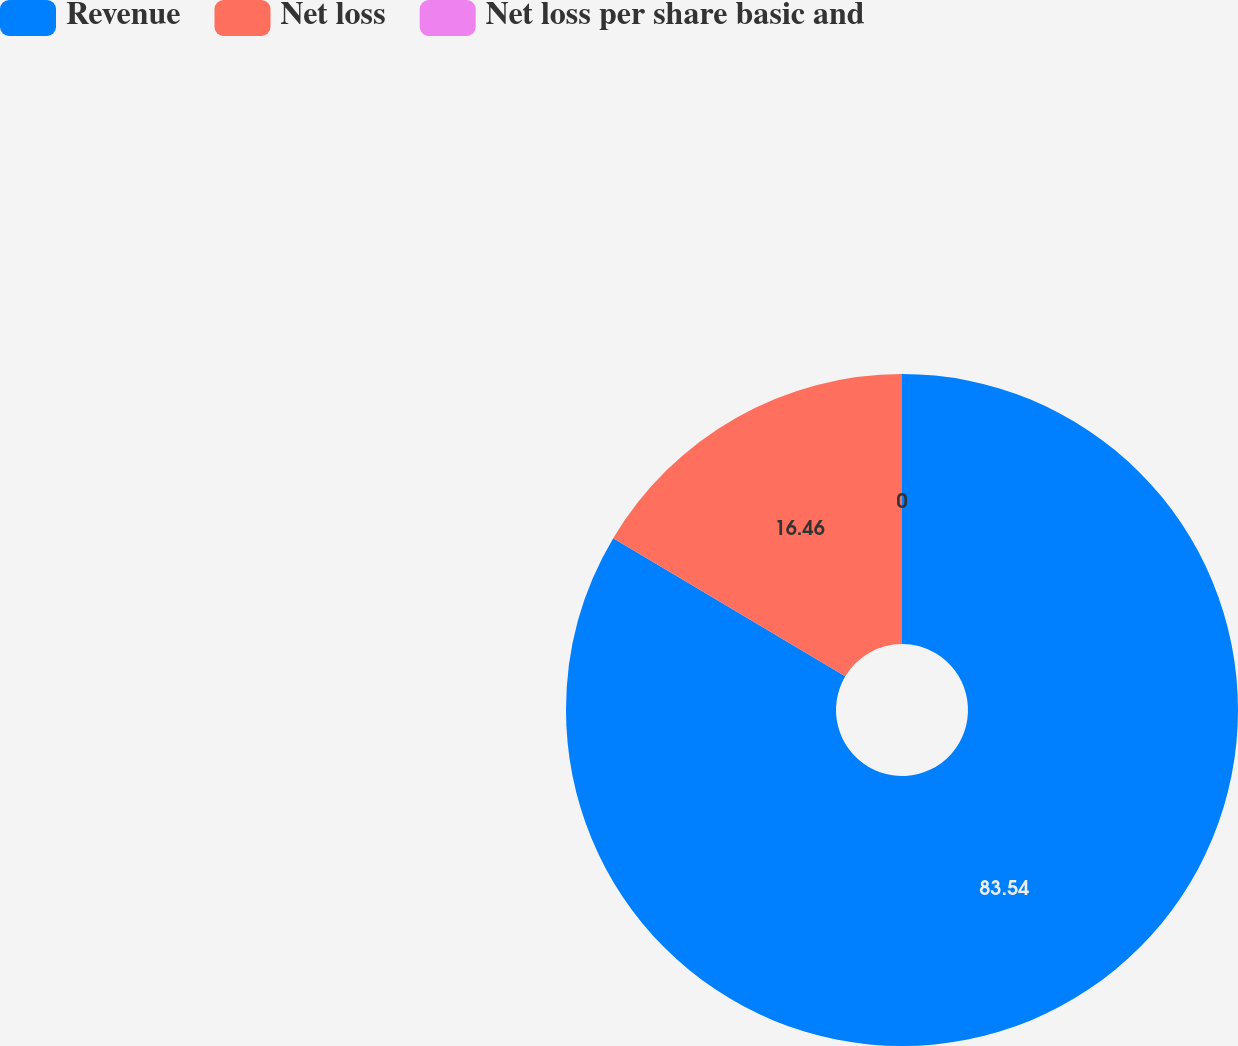Convert chart to OTSL. <chart><loc_0><loc_0><loc_500><loc_500><pie_chart><fcel>Revenue<fcel>Net loss<fcel>Net loss per share basic and<nl><fcel>83.54%<fcel>16.46%<fcel>0.0%<nl></chart> 